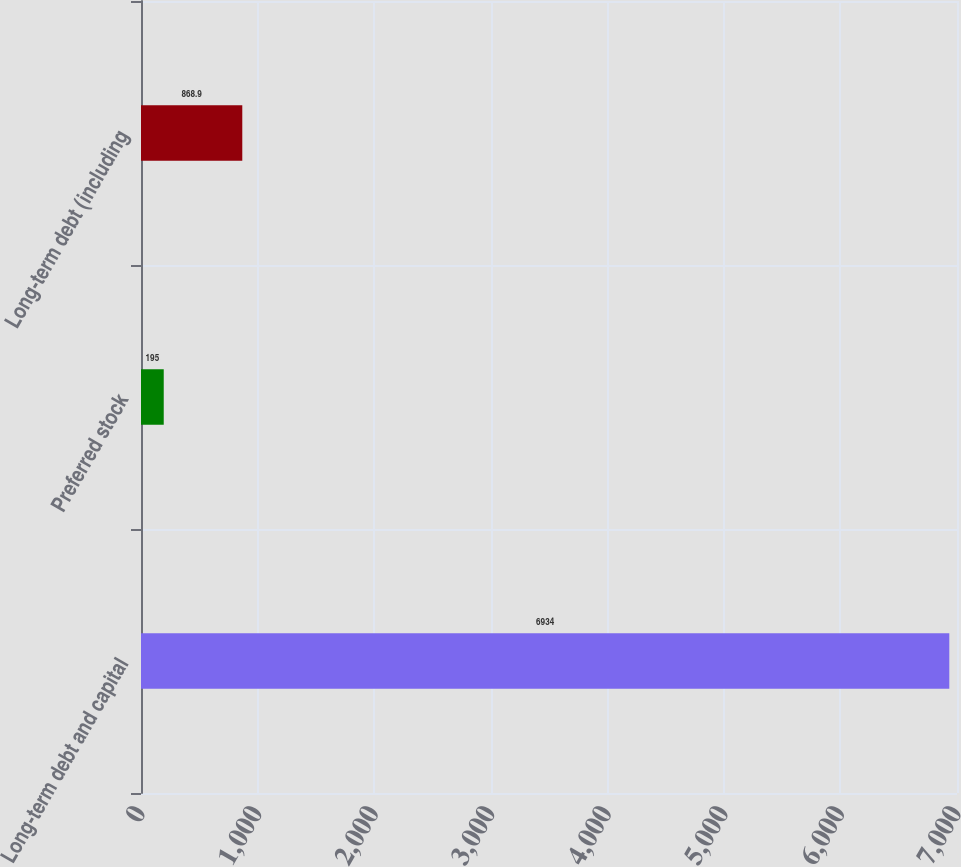<chart> <loc_0><loc_0><loc_500><loc_500><bar_chart><fcel>Long-term debt and capital<fcel>Preferred stock<fcel>Long-term debt (including<nl><fcel>6934<fcel>195<fcel>868.9<nl></chart> 